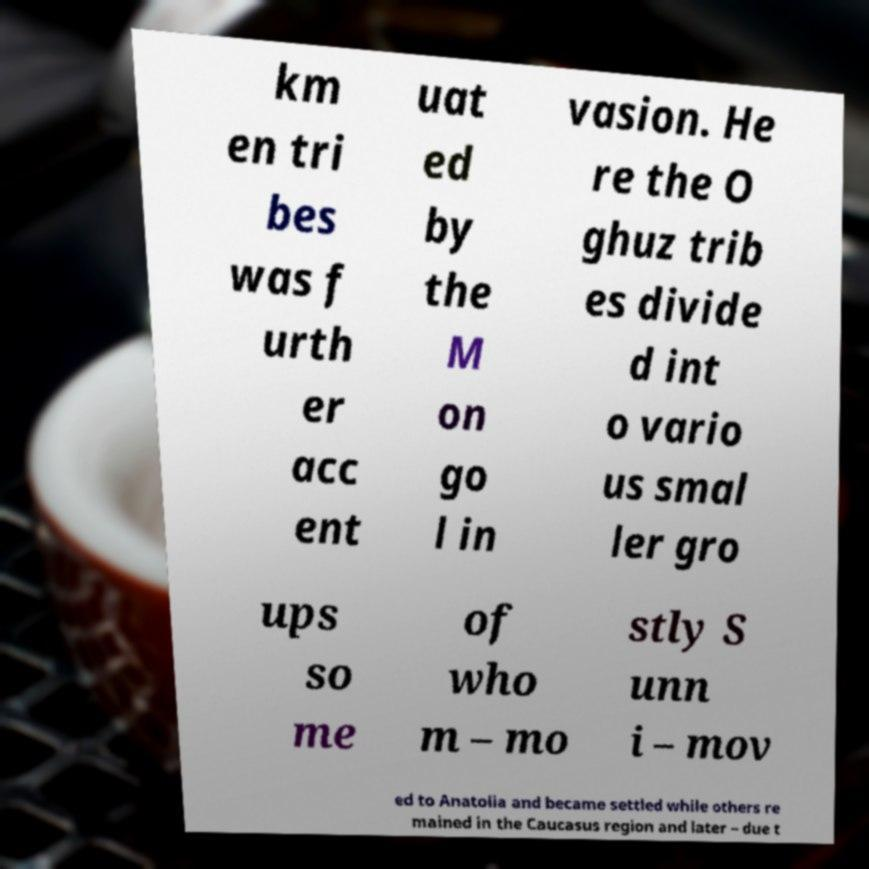Can you read and provide the text displayed in the image?This photo seems to have some interesting text. Can you extract and type it out for me? km en tri bes was f urth er acc ent uat ed by the M on go l in vasion. He re the O ghuz trib es divide d int o vario us smal ler gro ups so me of who m – mo stly S unn i – mov ed to Anatolia and became settled while others re mained in the Caucasus region and later – due t 